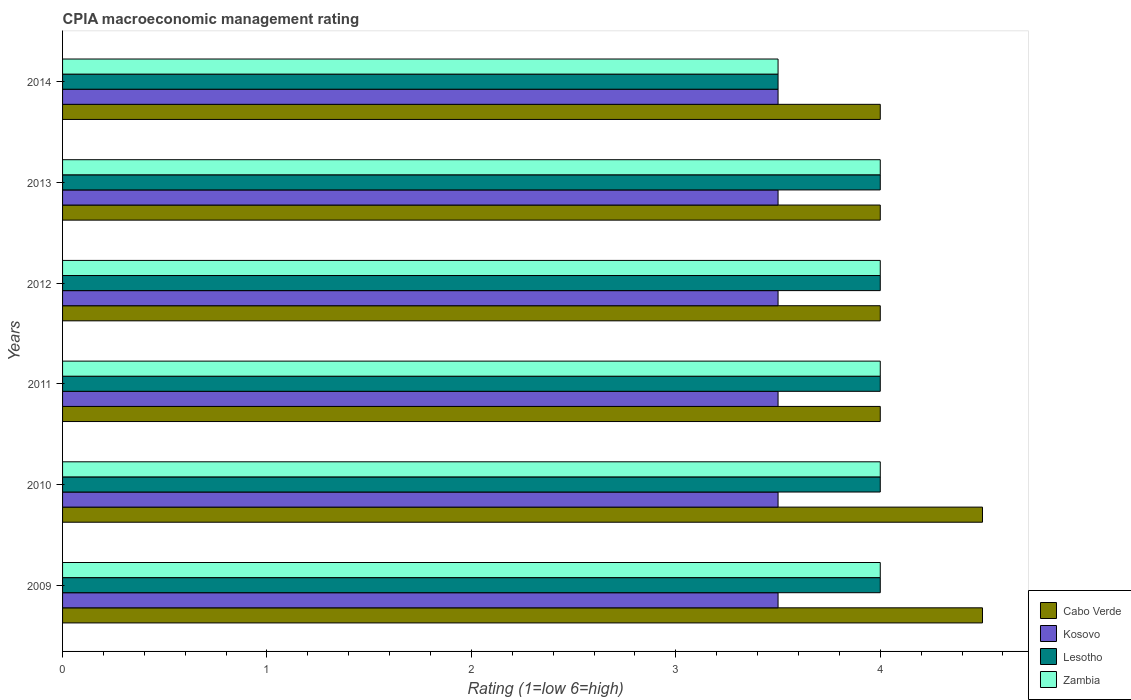How many different coloured bars are there?
Ensure brevity in your answer.  4. How many groups of bars are there?
Make the answer very short. 6. In which year was the CPIA rating in Zambia minimum?
Give a very brief answer. 2014. What is the difference between the CPIA rating in Cabo Verde in 2009 and that in 2013?
Provide a short and direct response. 0.5. What is the difference between the CPIA rating in Lesotho in 2014 and the CPIA rating in Zambia in 2013?
Ensure brevity in your answer.  -0.5. What is the average CPIA rating in Lesotho per year?
Provide a succinct answer. 3.92. In how many years, is the CPIA rating in Cabo Verde greater than 3 ?
Offer a terse response. 6. Is the CPIA rating in Kosovo in 2010 less than that in 2013?
Your answer should be very brief. No. Is the difference between the CPIA rating in Cabo Verde in 2009 and 2014 greater than the difference between the CPIA rating in Kosovo in 2009 and 2014?
Offer a terse response. Yes. What is the difference between the highest and the lowest CPIA rating in Cabo Verde?
Make the answer very short. 0.5. In how many years, is the CPIA rating in Zambia greater than the average CPIA rating in Zambia taken over all years?
Your response must be concise. 5. Is the sum of the CPIA rating in Kosovo in 2013 and 2014 greater than the maximum CPIA rating in Cabo Verde across all years?
Give a very brief answer. Yes. Is it the case that in every year, the sum of the CPIA rating in Kosovo and CPIA rating in Lesotho is greater than the sum of CPIA rating in Zambia and CPIA rating in Cabo Verde?
Ensure brevity in your answer.  No. What does the 3rd bar from the top in 2009 represents?
Offer a very short reply. Kosovo. What does the 1st bar from the bottom in 2012 represents?
Provide a short and direct response. Cabo Verde. Is it the case that in every year, the sum of the CPIA rating in Cabo Verde and CPIA rating in Zambia is greater than the CPIA rating in Kosovo?
Keep it short and to the point. Yes. How many bars are there?
Your answer should be compact. 24. Are all the bars in the graph horizontal?
Your answer should be compact. Yes. How many years are there in the graph?
Ensure brevity in your answer.  6. What is the difference between two consecutive major ticks on the X-axis?
Provide a short and direct response. 1. Does the graph contain grids?
Make the answer very short. No. Where does the legend appear in the graph?
Keep it short and to the point. Bottom right. What is the title of the graph?
Make the answer very short. CPIA macroeconomic management rating. What is the label or title of the Y-axis?
Ensure brevity in your answer.  Years. What is the Rating (1=low 6=high) of Lesotho in 2009?
Provide a short and direct response. 4. What is the Rating (1=low 6=high) in Zambia in 2010?
Give a very brief answer. 4. What is the Rating (1=low 6=high) of Cabo Verde in 2011?
Offer a very short reply. 4. What is the Rating (1=low 6=high) in Kosovo in 2011?
Your response must be concise. 3.5. What is the Rating (1=low 6=high) in Lesotho in 2011?
Keep it short and to the point. 4. What is the Rating (1=low 6=high) of Zambia in 2011?
Provide a succinct answer. 4. What is the Rating (1=low 6=high) of Lesotho in 2012?
Give a very brief answer. 4. What is the Rating (1=low 6=high) of Lesotho in 2013?
Provide a succinct answer. 4. What is the Rating (1=low 6=high) of Cabo Verde in 2014?
Your response must be concise. 4. What is the Rating (1=low 6=high) in Kosovo in 2014?
Your answer should be very brief. 3.5. What is the Rating (1=low 6=high) in Zambia in 2014?
Give a very brief answer. 3.5. Across all years, what is the maximum Rating (1=low 6=high) of Kosovo?
Your answer should be very brief. 3.5. Across all years, what is the maximum Rating (1=low 6=high) of Lesotho?
Offer a terse response. 4. Across all years, what is the minimum Rating (1=low 6=high) in Cabo Verde?
Provide a short and direct response. 4. Across all years, what is the minimum Rating (1=low 6=high) of Kosovo?
Your answer should be compact. 3.5. Across all years, what is the minimum Rating (1=low 6=high) of Zambia?
Your response must be concise. 3.5. What is the total Rating (1=low 6=high) of Cabo Verde in the graph?
Your response must be concise. 25. What is the total Rating (1=low 6=high) in Kosovo in the graph?
Your answer should be compact. 21. What is the difference between the Rating (1=low 6=high) of Cabo Verde in 2009 and that in 2010?
Give a very brief answer. 0. What is the difference between the Rating (1=low 6=high) in Lesotho in 2009 and that in 2010?
Keep it short and to the point. 0. What is the difference between the Rating (1=low 6=high) of Cabo Verde in 2009 and that in 2011?
Make the answer very short. 0.5. What is the difference between the Rating (1=low 6=high) in Kosovo in 2009 and that in 2011?
Offer a very short reply. 0. What is the difference between the Rating (1=low 6=high) of Lesotho in 2009 and that in 2011?
Your answer should be very brief. 0. What is the difference between the Rating (1=low 6=high) of Zambia in 2009 and that in 2011?
Keep it short and to the point. 0. What is the difference between the Rating (1=low 6=high) of Kosovo in 2009 and that in 2012?
Offer a terse response. 0. What is the difference between the Rating (1=low 6=high) in Zambia in 2009 and that in 2012?
Ensure brevity in your answer.  0. What is the difference between the Rating (1=low 6=high) in Cabo Verde in 2009 and that in 2013?
Provide a short and direct response. 0.5. What is the difference between the Rating (1=low 6=high) of Lesotho in 2009 and that in 2013?
Provide a succinct answer. 0. What is the difference between the Rating (1=low 6=high) in Lesotho in 2009 and that in 2014?
Make the answer very short. 0.5. What is the difference between the Rating (1=low 6=high) of Cabo Verde in 2010 and that in 2011?
Offer a very short reply. 0.5. What is the difference between the Rating (1=low 6=high) of Kosovo in 2010 and that in 2011?
Your response must be concise. 0. What is the difference between the Rating (1=low 6=high) in Lesotho in 2010 and that in 2011?
Provide a short and direct response. 0. What is the difference between the Rating (1=low 6=high) of Cabo Verde in 2010 and that in 2012?
Your answer should be very brief. 0.5. What is the difference between the Rating (1=low 6=high) in Kosovo in 2010 and that in 2012?
Your answer should be compact. 0. What is the difference between the Rating (1=low 6=high) of Zambia in 2010 and that in 2012?
Keep it short and to the point. 0. What is the difference between the Rating (1=low 6=high) of Kosovo in 2010 and that in 2013?
Your response must be concise. 0. What is the difference between the Rating (1=low 6=high) of Kosovo in 2010 and that in 2014?
Provide a short and direct response. 0. What is the difference between the Rating (1=low 6=high) of Zambia in 2010 and that in 2014?
Your answer should be very brief. 0.5. What is the difference between the Rating (1=low 6=high) of Cabo Verde in 2011 and that in 2012?
Keep it short and to the point. 0. What is the difference between the Rating (1=low 6=high) of Kosovo in 2011 and that in 2012?
Your answer should be very brief. 0. What is the difference between the Rating (1=low 6=high) of Lesotho in 2011 and that in 2012?
Give a very brief answer. 0. What is the difference between the Rating (1=low 6=high) of Kosovo in 2011 and that in 2013?
Provide a succinct answer. 0. What is the difference between the Rating (1=low 6=high) of Lesotho in 2011 and that in 2013?
Ensure brevity in your answer.  0. What is the difference between the Rating (1=low 6=high) of Zambia in 2011 and that in 2013?
Your answer should be very brief. 0. What is the difference between the Rating (1=low 6=high) of Cabo Verde in 2011 and that in 2014?
Provide a short and direct response. 0. What is the difference between the Rating (1=low 6=high) in Kosovo in 2011 and that in 2014?
Your answer should be compact. 0. What is the difference between the Rating (1=low 6=high) of Kosovo in 2012 and that in 2013?
Make the answer very short. 0. What is the difference between the Rating (1=low 6=high) of Lesotho in 2012 and that in 2014?
Your answer should be compact. 0.5. What is the difference between the Rating (1=low 6=high) of Cabo Verde in 2013 and that in 2014?
Your answer should be compact. 0. What is the difference between the Rating (1=low 6=high) of Cabo Verde in 2009 and the Rating (1=low 6=high) of Lesotho in 2010?
Offer a terse response. 0.5. What is the difference between the Rating (1=low 6=high) of Lesotho in 2009 and the Rating (1=low 6=high) of Zambia in 2010?
Offer a terse response. 0. What is the difference between the Rating (1=low 6=high) in Cabo Verde in 2009 and the Rating (1=low 6=high) in Kosovo in 2011?
Ensure brevity in your answer.  1. What is the difference between the Rating (1=low 6=high) of Cabo Verde in 2009 and the Rating (1=low 6=high) of Kosovo in 2012?
Ensure brevity in your answer.  1. What is the difference between the Rating (1=low 6=high) of Cabo Verde in 2009 and the Rating (1=low 6=high) of Zambia in 2012?
Provide a short and direct response. 0.5. What is the difference between the Rating (1=low 6=high) in Kosovo in 2009 and the Rating (1=low 6=high) in Lesotho in 2012?
Provide a short and direct response. -0.5. What is the difference between the Rating (1=low 6=high) in Kosovo in 2009 and the Rating (1=low 6=high) in Zambia in 2012?
Your answer should be compact. -0.5. What is the difference between the Rating (1=low 6=high) in Lesotho in 2009 and the Rating (1=low 6=high) in Zambia in 2012?
Provide a short and direct response. 0. What is the difference between the Rating (1=low 6=high) of Cabo Verde in 2009 and the Rating (1=low 6=high) of Zambia in 2013?
Give a very brief answer. 0.5. What is the difference between the Rating (1=low 6=high) of Kosovo in 2009 and the Rating (1=low 6=high) of Lesotho in 2013?
Your answer should be very brief. -0.5. What is the difference between the Rating (1=low 6=high) in Lesotho in 2009 and the Rating (1=low 6=high) in Zambia in 2013?
Keep it short and to the point. 0. What is the difference between the Rating (1=low 6=high) in Cabo Verde in 2009 and the Rating (1=low 6=high) in Zambia in 2014?
Provide a short and direct response. 1. What is the difference between the Rating (1=low 6=high) of Kosovo in 2009 and the Rating (1=low 6=high) of Lesotho in 2014?
Give a very brief answer. 0. What is the difference between the Rating (1=low 6=high) in Kosovo in 2009 and the Rating (1=low 6=high) in Zambia in 2014?
Keep it short and to the point. 0. What is the difference between the Rating (1=low 6=high) of Lesotho in 2009 and the Rating (1=low 6=high) of Zambia in 2014?
Give a very brief answer. 0.5. What is the difference between the Rating (1=low 6=high) of Cabo Verde in 2010 and the Rating (1=low 6=high) of Zambia in 2011?
Offer a very short reply. 0.5. What is the difference between the Rating (1=low 6=high) of Cabo Verde in 2010 and the Rating (1=low 6=high) of Kosovo in 2012?
Offer a terse response. 1. What is the difference between the Rating (1=low 6=high) of Kosovo in 2010 and the Rating (1=low 6=high) of Zambia in 2012?
Your answer should be very brief. -0.5. What is the difference between the Rating (1=low 6=high) of Lesotho in 2010 and the Rating (1=low 6=high) of Zambia in 2012?
Your response must be concise. 0. What is the difference between the Rating (1=low 6=high) of Cabo Verde in 2010 and the Rating (1=low 6=high) of Lesotho in 2013?
Your answer should be compact. 0.5. What is the difference between the Rating (1=low 6=high) of Kosovo in 2010 and the Rating (1=low 6=high) of Lesotho in 2013?
Provide a short and direct response. -0.5. What is the difference between the Rating (1=low 6=high) in Lesotho in 2010 and the Rating (1=low 6=high) in Zambia in 2013?
Provide a short and direct response. 0. What is the difference between the Rating (1=low 6=high) of Cabo Verde in 2010 and the Rating (1=low 6=high) of Kosovo in 2014?
Make the answer very short. 1. What is the difference between the Rating (1=low 6=high) in Cabo Verde in 2010 and the Rating (1=low 6=high) in Lesotho in 2014?
Provide a succinct answer. 1. What is the difference between the Rating (1=low 6=high) of Kosovo in 2010 and the Rating (1=low 6=high) of Lesotho in 2014?
Provide a succinct answer. 0. What is the difference between the Rating (1=low 6=high) of Kosovo in 2010 and the Rating (1=low 6=high) of Zambia in 2014?
Provide a short and direct response. 0. What is the difference between the Rating (1=low 6=high) in Cabo Verde in 2011 and the Rating (1=low 6=high) in Kosovo in 2012?
Ensure brevity in your answer.  0.5. What is the difference between the Rating (1=low 6=high) of Cabo Verde in 2011 and the Rating (1=low 6=high) of Lesotho in 2012?
Your answer should be compact. 0. What is the difference between the Rating (1=low 6=high) of Cabo Verde in 2011 and the Rating (1=low 6=high) of Zambia in 2012?
Your answer should be very brief. 0. What is the difference between the Rating (1=low 6=high) of Lesotho in 2011 and the Rating (1=low 6=high) of Zambia in 2012?
Offer a very short reply. 0. What is the difference between the Rating (1=low 6=high) in Cabo Verde in 2011 and the Rating (1=low 6=high) in Lesotho in 2013?
Provide a succinct answer. 0. What is the difference between the Rating (1=low 6=high) in Kosovo in 2011 and the Rating (1=low 6=high) in Lesotho in 2013?
Offer a terse response. -0.5. What is the difference between the Rating (1=low 6=high) in Cabo Verde in 2011 and the Rating (1=low 6=high) in Kosovo in 2014?
Provide a succinct answer. 0.5. What is the difference between the Rating (1=low 6=high) of Cabo Verde in 2011 and the Rating (1=low 6=high) of Zambia in 2014?
Your response must be concise. 0.5. What is the difference between the Rating (1=low 6=high) of Kosovo in 2011 and the Rating (1=low 6=high) of Lesotho in 2014?
Provide a short and direct response. 0. What is the difference between the Rating (1=low 6=high) of Kosovo in 2011 and the Rating (1=low 6=high) of Zambia in 2014?
Give a very brief answer. 0. What is the difference between the Rating (1=low 6=high) in Cabo Verde in 2012 and the Rating (1=low 6=high) in Lesotho in 2013?
Make the answer very short. 0. What is the difference between the Rating (1=low 6=high) in Lesotho in 2012 and the Rating (1=low 6=high) in Zambia in 2013?
Your answer should be very brief. 0. What is the difference between the Rating (1=low 6=high) in Cabo Verde in 2012 and the Rating (1=low 6=high) in Kosovo in 2014?
Offer a terse response. 0.5. What is the difference between the Rating (1=low 6=high) of Cabo Verde in 2012 and the Rating (1=low 6=high) of Lesotho in 2014?
Keep it short and to the point. 0.5. What is the difference between the Rating (1=low 6=high) of Cabo Verde in 2012 and the Rating (1=low 6=high) of Zambia in 2014?
Your answer should be compact. 0.5. What is the difference between the Rating (1=low 6=high) in Kosovo in 2012 and the Rating (1=low 6=high) in Zambia in 2014?
Your answer should be compact. 0. What is the difference between the Rating (1=low 6=high) in Lesotho in 2012 and the Rating (1=low 6=high) in Zambia in 2014?
Provide a short and direct response. 0.5. What is the difference between the Rating (1=low 6=high) in Cabo Verde in 2013 and the Rating (1=low 6=high) in Kosovo in 2014?
Provide a short and direct response. 0.5. What is the difference between the Rating (1=low 6=high) in Kosovo in 2013 and the Rating (1=low 6=high) in Zambia in 2014?
Offer a terse response. 0. What is the difference between the Rating (1=low 6=high) in Lesotho in 2013 and the Rating (1=low 6=high) in Zambia in 2014?
Your answer should be very brief. 0.5. What is the average Rating (1=low 6=high) of Cabo Verde per year?
Your answer should be very brief. 4.17. What is the average Rating (1=low 6=high) in Lesotho per year?
Offer a terse response. 3.92. What is the average Rating (1=low 6=high) in Zambia per year?
Your answer should be very brief. 3.92. In the year 2009, what is the difference between the Rating (1=low 6=high) of Cabo Verde and Rating (1=low 6=high) of Lesotho?
Offer a terse response. 0.5. In the year 2009, what is the difference between the Rating (1=low 6=high) of Kosovo and Rating (1=low 6=high) of Zambia?
Your answer should be very brief. -0.5. In the year 2010, what is the difference between the Rating (1=low 6=high) of Cabo Verde and Rating (1=low 6=high) of Lesotho?
Your answer should be compact. 0.5. In the year 2010, what is the difference between the Rating (1=low 6=high) of Cabo Verde and Rating (1=low 6=high) of Zambia?
Your response must be concise. 0.5. In the year 2011, what is the difference between the Rating (1=low 6=high) in Cabo Verde and Rating (1=low 6=high) in Kosovo?
Offer a terse response. 0.5. In the year 2011, what is the difference between the Rating (1=low 6=high) in Cabo Verde and Rating (1=low 6=high) in Lesotho?
Ensure brevity in your answer.  0. In the year 2011, what is the difference between the Rating (1=low 6=high) of Cabo Verde and Rating (1=low 6=high) of Zambia?
Offer a terse response. 0. In the year 2011, what is the difference between the Rating (1=low 6=high) in Kosovo and Rating (1=low 6=high) in Lesotho?
Your answer should be very brief. -0.5. In the year 2011, what is the difference between the Rating (1=low 6=high) in Kosovo and Rating (1=low 6=high) in Zambia?
Provide a short and direct response. -0.5. In the year 2012, what is the difference between the Rating (1=low 6=high) of Cabo Verde and Rating (1=low 6=high) of Zambia?
Ensure brevity in your answer.  0. In the year 2012, what is the difference between the Rating (1=low 6=high) of Kosovo and Rating (1=low 6=high) of Lesotho?
Keep it short and to the point. -0.5. In the year 2012, what is the difference between the Rating (1=low 6=high) in Kosovo and Rating (1=low 6=high) in Zambia?
Provide a short and direct response. -0.5. In the year 2012, what is the difference between the Rating (1=low 6=high) of Lesotho and Rating (1=low 6=high) of Zambia?
Provide a succinct answer. 0. In the year 2013, what is the difference between the Rating (1=low 6=high) of Cabo Verde and Rating (1=low 6=high) of Kosovo?
Provide a short and direct response. 0.5. In the year 2013, what is the difference between the Rating (1=low 6=high) in Lesotho and Rating (1=low 6=high) in Zambia?
Offer a terse response. 0. In the year 2014, what is the difference between the Rating (1=low 6=high) of Cabo Verde and Rating (1=low 6=high) of Kosovo?
Offer a very short reply. 0.5. In the year 2014, what is the difference between the Rating (1=low 6=high) in Cabo Verde and Rating (1=low 6=high) in Zambia?
Provide a succinct answer. 0.5. In the year 2014, what is the difference between the Rating (1=low 6=high) in Kosovo and Rating (1=low 6=high) in Lesotho?
Ensure brevity in your answer.  0. In the year 2014, what is the difference between the Rating (1=low 6=high) of Kosovo and Rating (1=low 6=high) of Zambia?
Provide a succinct answer. 0. What is the ratio of the Rating (1=low 6=high) in Kosovo in 2009 to that in 2010?
Your answer should be very brief. 1. What is the ratio of the Rating (1=low 6=high) of Lesotho in 2009 to that in 2010?
Your answer should be very brief. 1. What is the ratio of the Rating (1=low 6=high) of Cabo Verde in 2009 to that in 2011?
Keep it short and to the point. 1.12. What is the ratio of the Rating (1=low 6=high) of Kosovo in 2009 to that in 2011?
Make the answer very short. 1. What is the ratio of the Rating (1=low 6=high) in Zambia in 2009 to that in 2011?
Ensure brevity in your answer.  1. What is the ratio of the Rating (1=low 6=high) of Cabo Verde in 2009 to that in 2012?
Ensure brevity in your answer.  1.12. What is the ratio of the Rating (1=low 6=high) of Lesotho in 2009 to that in 2012?
Ensure brevity in your answer.  1. What is the ratio of the Rating (1=low 6=high) of Kosovo in 2009 to that in 2013?
Offer a terse response. 1. What is the ratio of the Rating (1=low 6=high) in Lesotho in 2009 to that in 2013?
Offer a terse response. 1. What is the ratio of the Rating (1=low 6=high) of Zambia in 2009 to that in 2013?
Offer a terse response. 1. What is the ratio of the Rating (1=low 6=high) of Cabo Verde in 2009 to that in 2014?
Give a very brief answer. 1.12. What is the ratio of the Rating (1=low 6=high) in Lesotho in 2009 to that in 2014?
Give a very brief answer. 1.14. What is the ratio of the Rating (1=low 6=high) of Kosovo in 2010 to that in 2011?
Your response must be concise. 1. What is the ratio of the Rating (1=low 6=high) of Lesotho in 2010 to that in 2011?
Ensure brevity in your answer.  1. What is the ratio of the Rating (1=low 6=high) in Cabo Verde in 2010 to that in 2012?
Make the answer very short. 1.12. What is the ratio of the Rating (1=low 6=high) in Lesotho in 2010 to that in 2012?
Make the answer very short. 1. What is the ratio of the Rating (1=low 6=high) in Zambia in 2010 to that in 2012?
Keep it short and to the point. 1. What is the ratio of the Rating (1=low 6=high) of Kosovo in 2010 to that in 2013?
Keep it short and to the point. 1. What is the ratio of the Rating (1=low 6=high) of Lesotho in 2010 to that in 2013?
Your answer should be very brief. 1. What is the ratio of the Rating (1=low 6=high) of Zambia in 2010 to that in 2013?
Your answer should be very brief. 1. What is the ratio of the Rating (1=low 6=high) in Cabo Verde in 2010 to that in 2014?
Your response must be concise. 1.12. What is the ratio of the Rating (1=low 6=high) in Kosovo in 2010 to that in 2014?
Give a very brief answer. 1. What is the ratio of the Rating (1=low 6=high) in Lesotho in 2010 to that in 2014?
Your response must be concise. 1.14. What is the ratio of the Rating (1=low 6=high) of Zambia in 2010 to that in 2014?
Your response must be concise. 1.14. What is the ratio of the Rating (1=low 6=high) in Cabo Verde in 2011 to that in 2012?
Give a very brief answer. 1. What is the ratio of the Rating (1=low 6=high) in Zambia in 2011 to that in 2012?
Offer a terse response. 1. What is the ratio of the Rating (1=low 6=high) of Kosovo in 2011 to that in 2013?
Provide a succinct answer. 1. What is the ratio of the Rating (1=low 6=high) in Zambia in 2011 to that in 2013?
Offer a very short reply. 1. What is the ratio of the Rating (1=low 6=high) of Lesotho in 2011 to that in 2014?
Keep it short and to the point. 1.14. What is the ratio of the Rating (1=low 6=high) in Zambia in 2011 to that in 2014?
Keep it short and to the point. 1.14. What is the ratio of the Rating (1=low 6=high) of Cabo Verde in 2012 to that in 2013?
Offer a terse response. 1. What is the ratio of the Rating (1=low 6=high) in Lesotho in 2012 to that in 2013?
Your answer should be very brief. 1. What is the ratio of the Rating (1=low 6=high) in Zambia in 2012 to that in 2013?
Your answer should be very brief. 1. What is the ratio of the Rating (1=low 6=high) in Lesotho in 2012 to that in 2014?
Make the answer very short. 1.14. What is the ratio of the Rating (1=low 6=high) in Zambia in 2012 to that in 2014?
Provide a succinct answer. 1.14. What is the ratio of the Rating (1=low 6=high) of Kosovo in 2013 to that in 2014?
Ensure brevity in your answer.  1. What is the ratio of the Rating (1=low 6=high) of Lesotho in 2013 to that in 2014?
Your response must be concise. 1.14. What is the ratio of the Rating (1=low 6=high) of Zambia in 2013 to that in 2014?
Offer a very short reply. 1.14. What is the difference between the highest and the second highest Rating (1=low 6=high) of Zambia?
Offer a terse response. 0. What is the difference between the highest and the lowest Rating (1=low 6=high) in Lesotho?
Your answer should be compact. 0.5. 